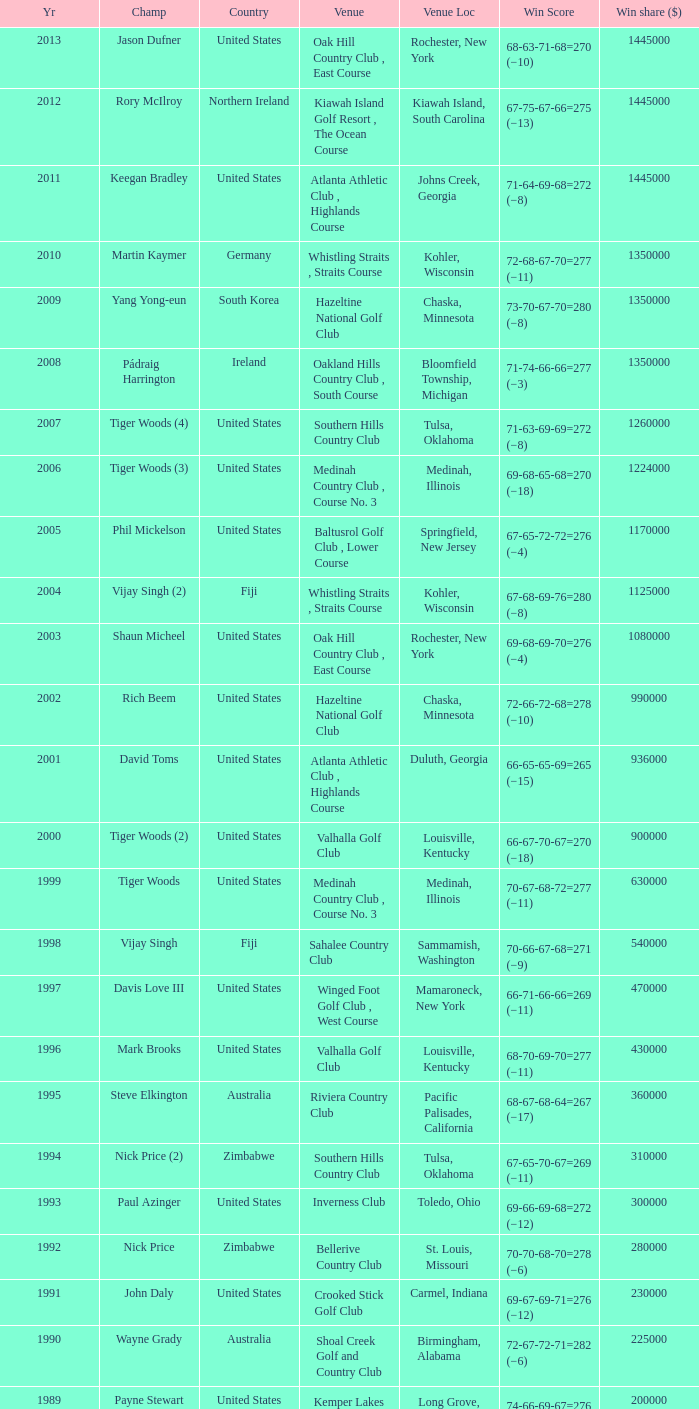List all winning scores from 1982. 63-69-68-72=272 (−8). 